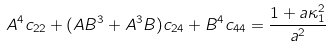Convert formula to latex. <formula><loc_0><loc_0><loc_500><loc_500>A ^ { 4 } c _ { 2 2 } + ( A B ^ { 3 } + A ^ { 3 } B ) c _ { 2 4 } + B ^ { 4 } c _ { 4 4 } = \frac { 1 + a \kappa _ { 1 } ^ { 2 } } { a ^ { 2 } }</formula> 